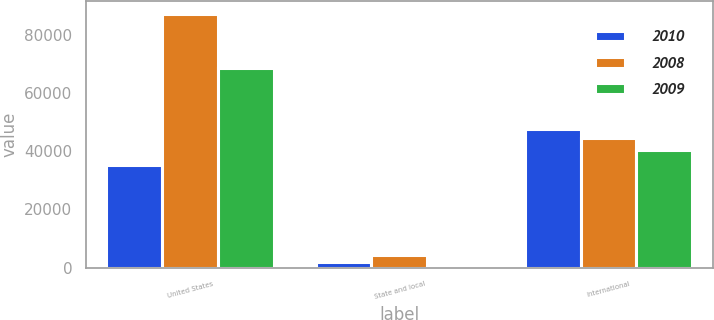Convert chart to OTSL. <chart><loc_0><loc_0><loc_500><loc_500><stacked_bar_chart><ecel><fcel>United States<fcel>State and local<fcel>International<nl><fcel>2010<fcel>35232<fcel>1931<fcel>47633<nl><fcel>2008<fcel>87053<fcel>4142<fcel>44436<nl><fcel>2009<fcel>68514<fcel>251<fcel>40530<nl></chart> 